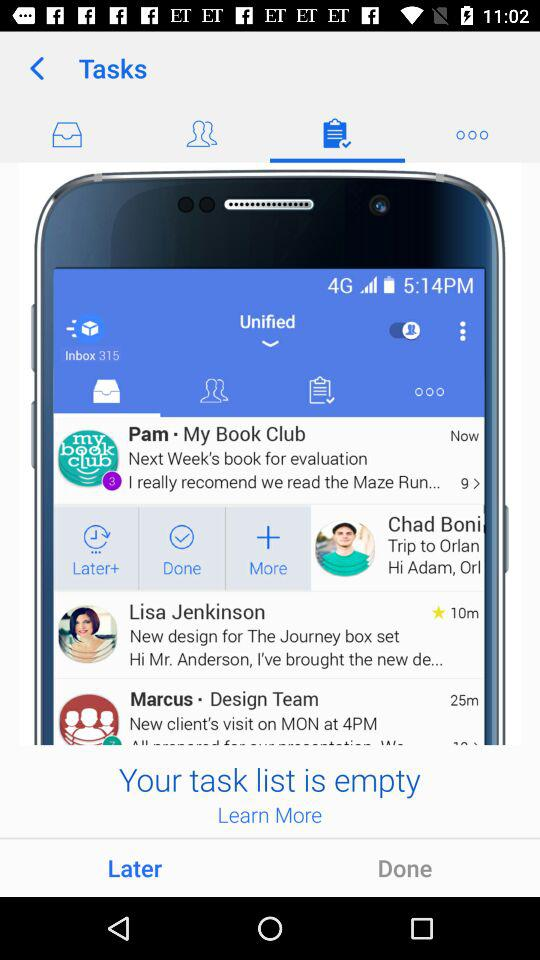Which tab is selected?
When the provided information is insufficient, respond with <no answer>. <no answer> 